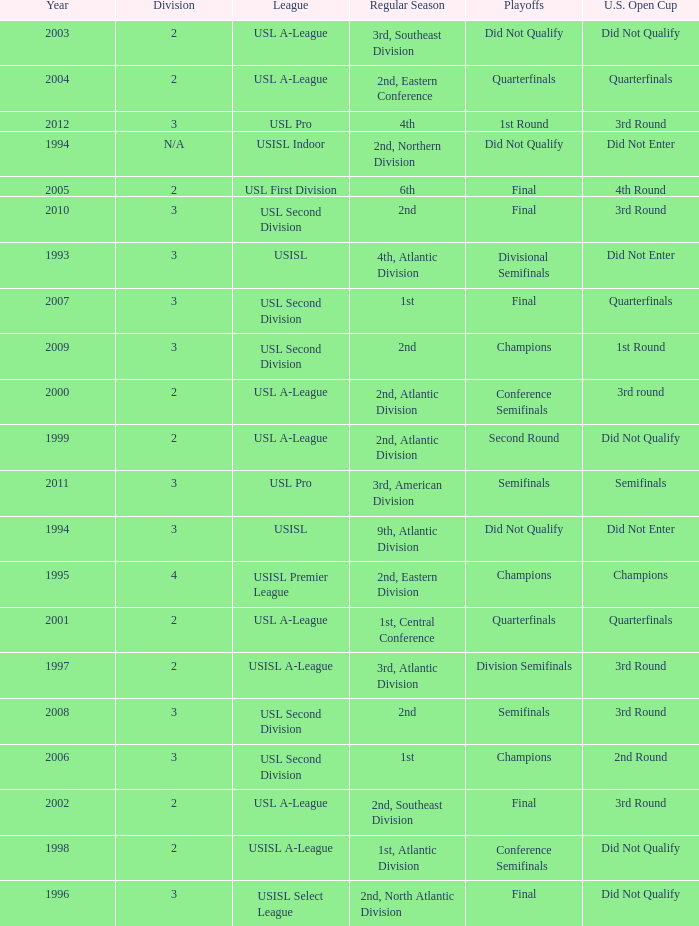What are all the playoffs for u.s. open cup in 1st round Champions. 